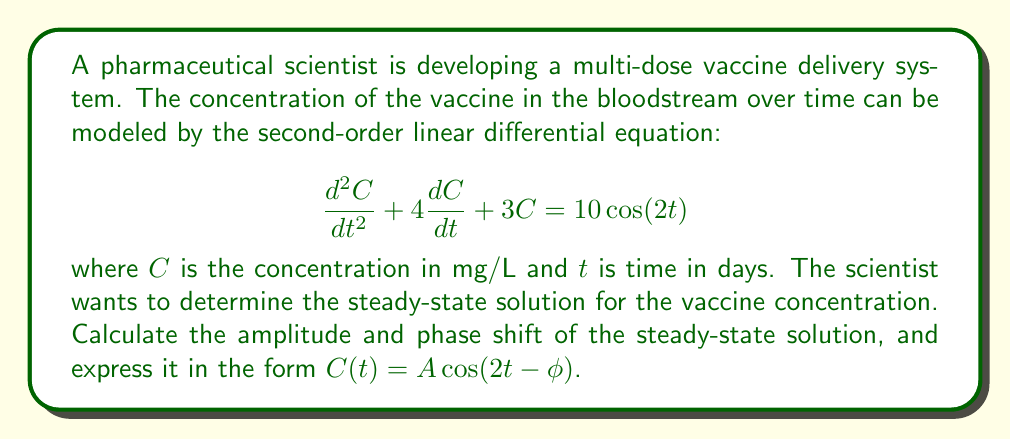Give your solution to this math problem. To solve this problem, we'll follow these steps:

1) The general form of a second-order linear differential equation with a cosine forcing function is:

   $$\frac{d^2y}{dt^2} + 2\zeta\omega_n\frac{dy}{dt} + \omega_n^2y = F_0\cos(\omega t)$$

2) Comparing our equation to this general form, we can identify:
   $2\zeta\omega_n = 4$
   $\omega_n^2 = 3$
   $F_0 = 10$
   $\omega = 2$

3) The steady-state solution for this type of equation is of the form:

   $$y(t) = A\cos(\omega t - \phi)$$

   where $A$ is the amplitude and $\phi$ is the phase shift.

4) The amplitude $A$ can be calculated using:

   $$A = \frac{F_0}{\sqrt{(\omega_n^2 - \omega^2)^2 + (2\zeta\omega_n\omega)^2}}$$

5) Substituting the values:

   $$A = \frac{10}{\sqrt{(3 - 2^2)^2 + (4 \cdot 2)^2}} = \frac{10}{\sqrt{1^2 + 8^2}} = \frac{10}{\sqrt{65}} \approx 1.24$$

6) The phase shift $\phi$ can be calculated using:

   $$\phi = \tan^{-1}\left(\frac{2\zeta\omega_n\omega}{\omega_n^2 - \omega^2}\right)$$

7) Substituting the values:

   $$\phi = \tan^{-1}\left(\frac{4 \cdot 2}{3 - 2^2}\right) = \tan^{-1}(8) \approx 1.45 \text{ radians}$$

Therefore, the steady-state solution is:

$$C(t) = \frac{10}{\sqrt{65}}\cos(2t - 1.45)$$
Answer: The steady-state solution is $C(t) = \frac{10}{\sqrt{65}}\cos(2t - 1.45)$, where the amplitude $A \approx 1.24$ mg/L and the phase shift $\phi \approx 1.45$ radians. 